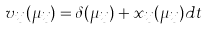<formula> <loc_0><loc_0><loc_500><loc_500>v _ { i j } ( \mu _ { i j } ) = \delta ( \mu _ { i j } ) + x _ { i j } ( \mu _ { i j } ) d t</formula> 